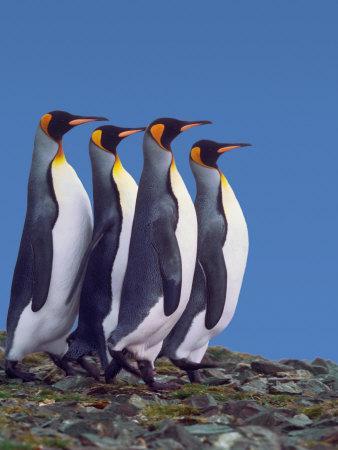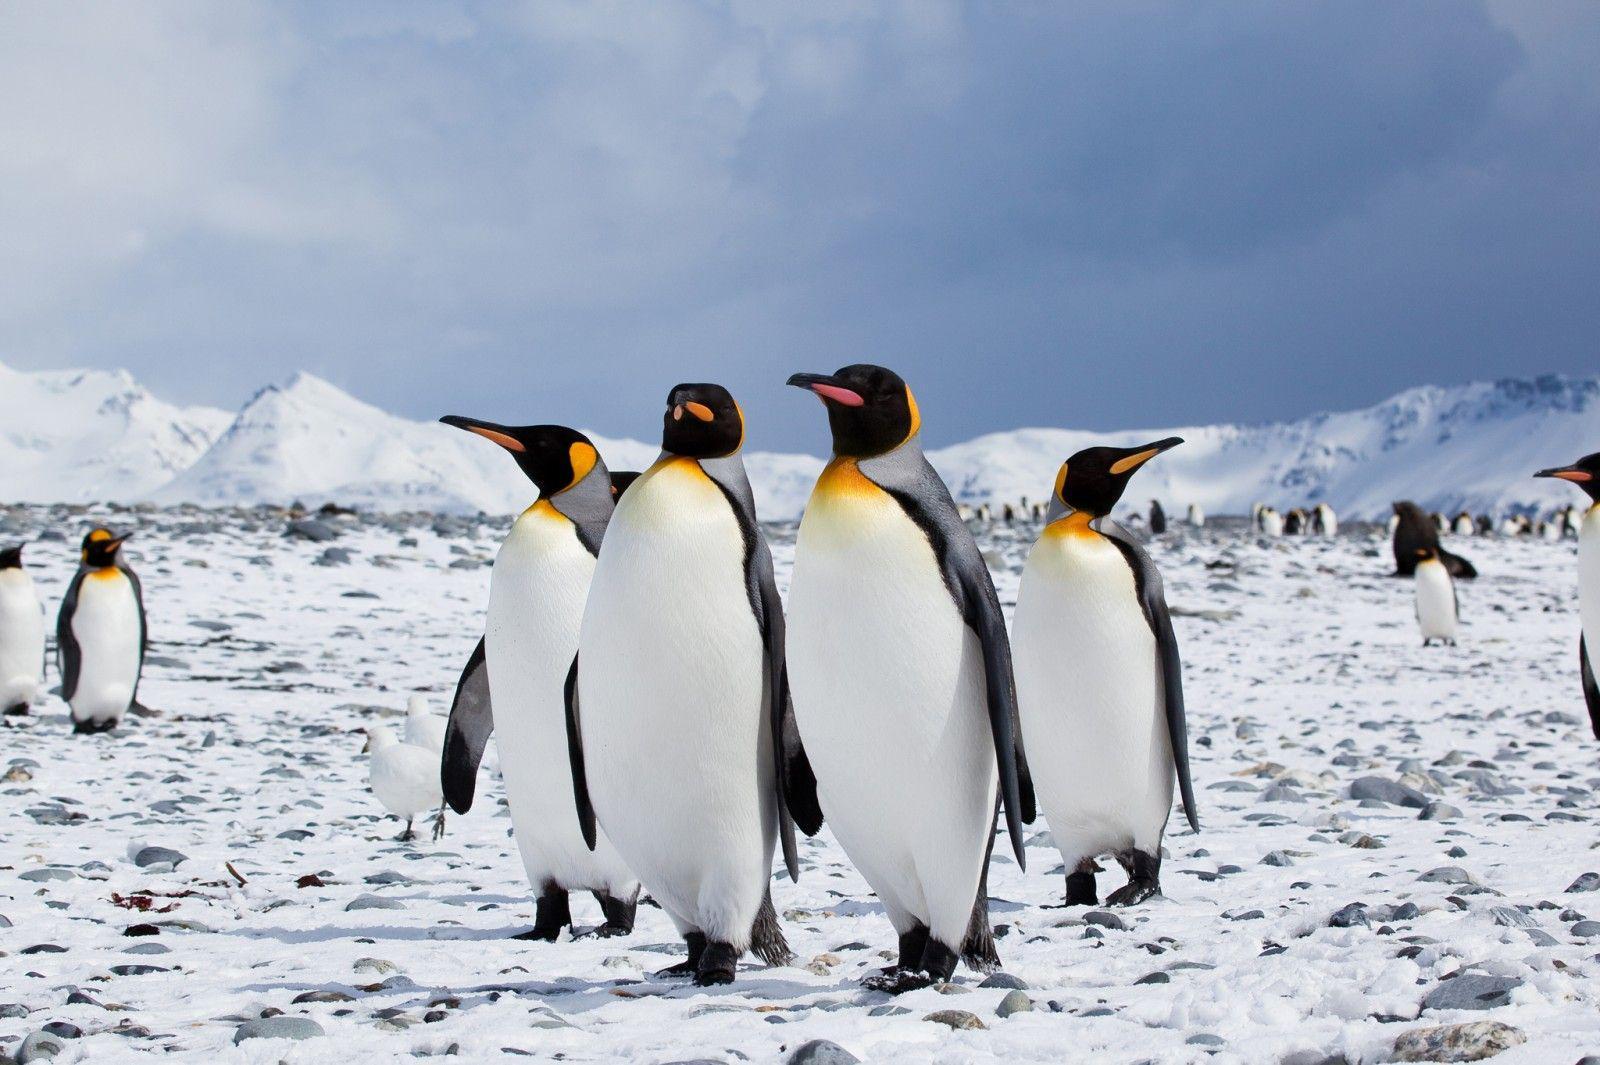The first image is the image on the left, the second image is the image on the right. Assess this claim about the two images: "There are two penguins". Correct or not? Answer yes or no. No. The first image is the image on the left, the second image is the image on the right. For the images displayed, is the sentence "multiple peguins white bellies are facing the camera" factually correct? Answer yes or no. Yes. The first image is the image on the left, the second image is the image on the right. Analyze the images presented: Is the assertion "An image shows a horizontal row of upright penguins, all facing right." valid? Answer yes or no. Yes. The first image is the image on the left, the second image is the image on the right. Given the left and right images, does the statement "There are no more than two penguins in the image on the left." hold true? Answer yes or no. No. The first image is the image on the left, the second image is the image on the right. Given the left and right images, does the statement "An image contains no more than two penguins, and includes a penguin with some fuzzy non-sleek feathers." hold true? Answer yes or no. No. 